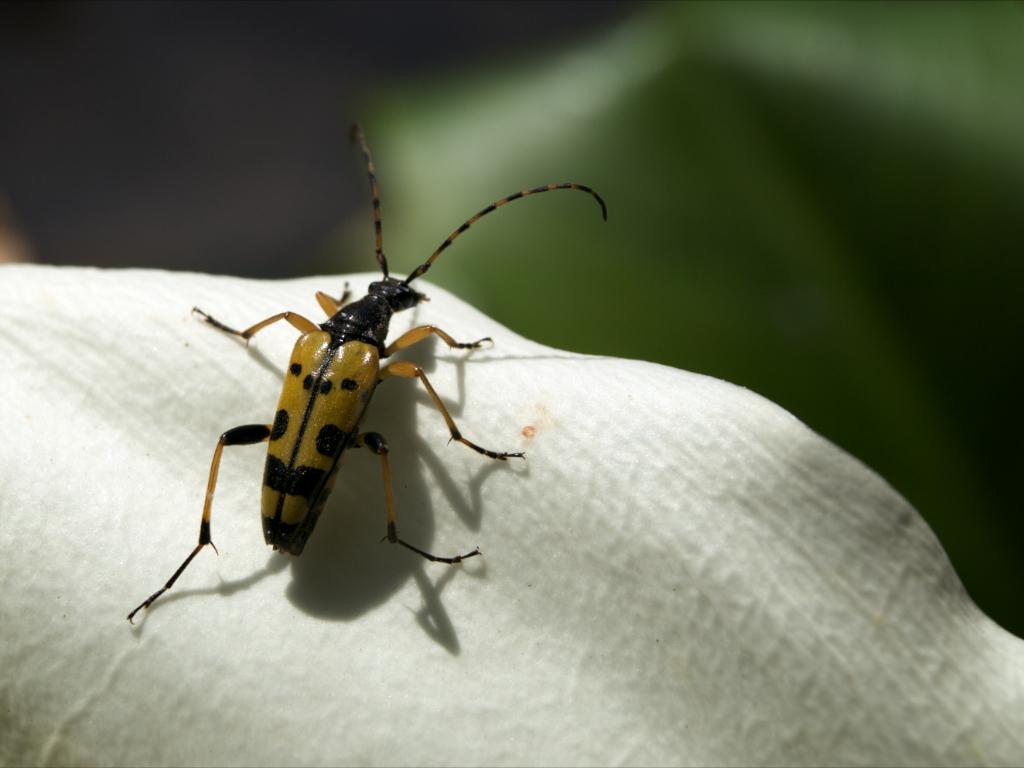What type of creature is present in the image? There is an insect in the image. What can be seen at the bottom of the image? There is a flower petal in white color at the bottom of the image. How would you describe the background of the image? The background of the image is blurred. What type of produce is being harvested in the image? There is no produce being harvested in the image; it features an insect and a flower petal. Is there a hook visible in the image? No, there is no hook present in the image. 